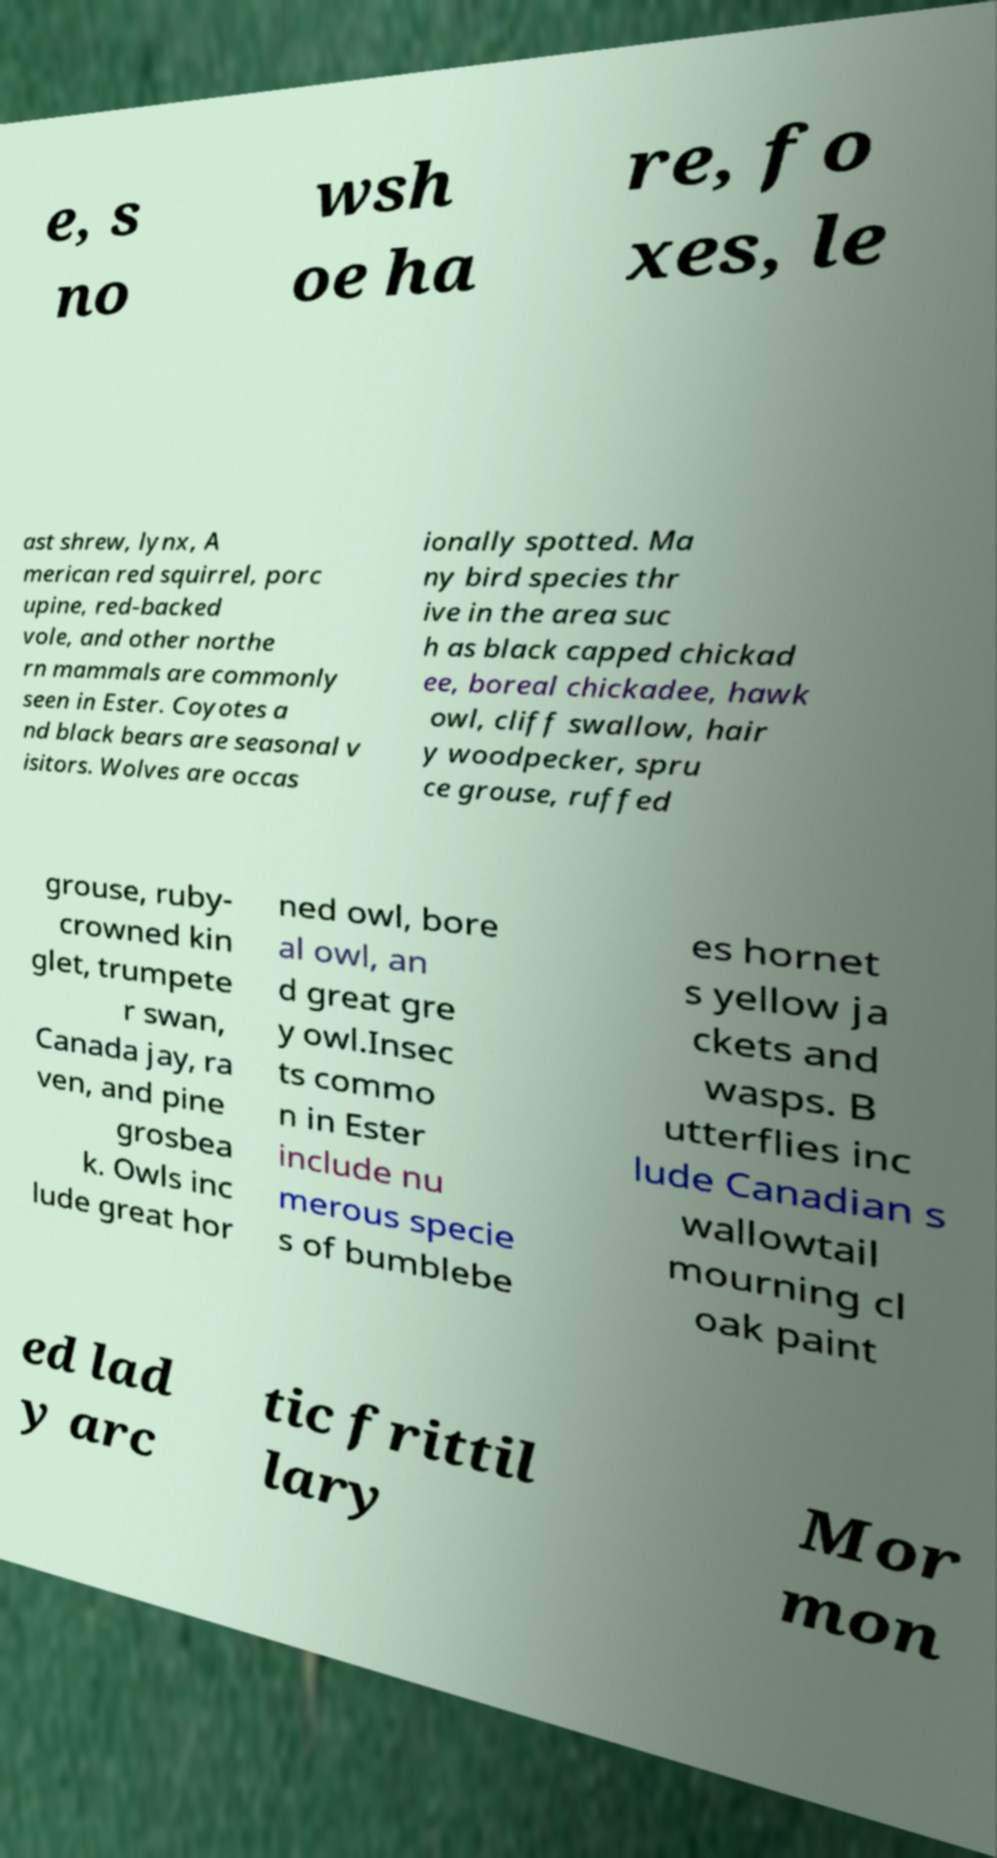What messages or text are displayed in this image? I need them in a readable, typed format. e, s no wsh oe ha re, fo xes, le ast shrew, lynx, A merican red squirrel, porc upine, red-backed vole, and other northe rn mammals are commonly seen in Ester. Coyotes a nd black bears are seasonal v isitors. Wolves are occas ionally spotted. Ma ny bird species thr ive in the area suc h as black capped chickad ee, boreal chickadee, hawk owl, cliff swallow, hair y woodpecker, spru ce grouse, ruffed grouse, ruby- crowned kin glet, trumpete r swan, Canada jay, ra ven, and pine grosbea k. Owls inc lude great hor ned owl, bore al owl, an d great gre y owl.Insec ts commo n in Ester include nu merous specie s of bumblebe es hornet s yellow ja ckets and wasps. B utterflies inc lude Canadian s wallowtail mourning cl oak paint ed lad y arc tic frittil lary Mor mon 